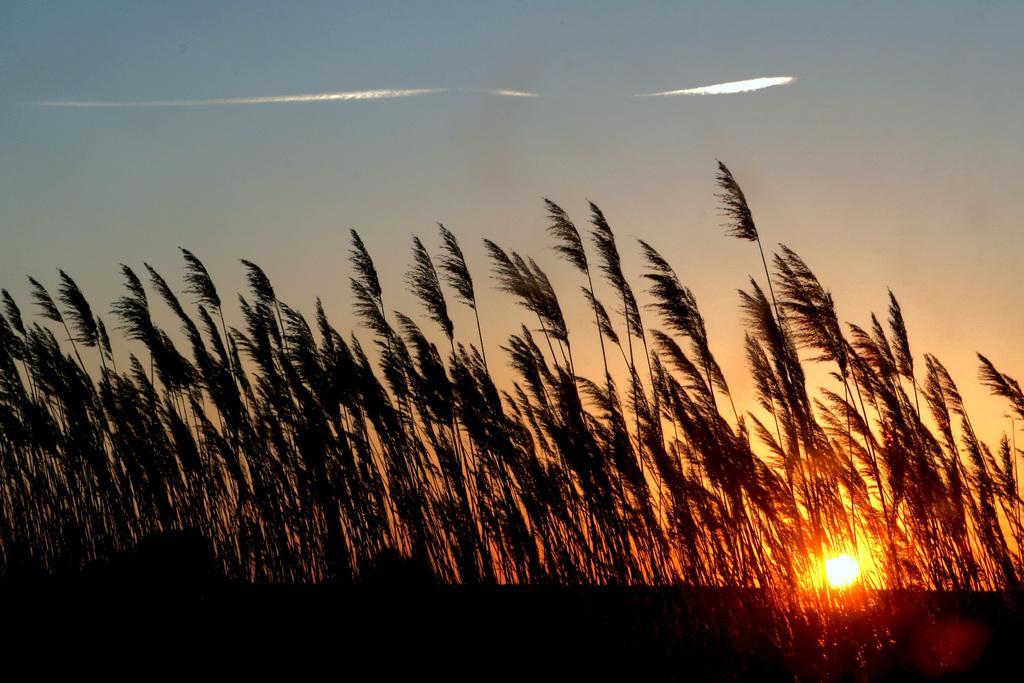In one or two sentences, can you explain what this image depicts? In this image in the center there are some trees and there is sun, at the top of the image there is sky. 